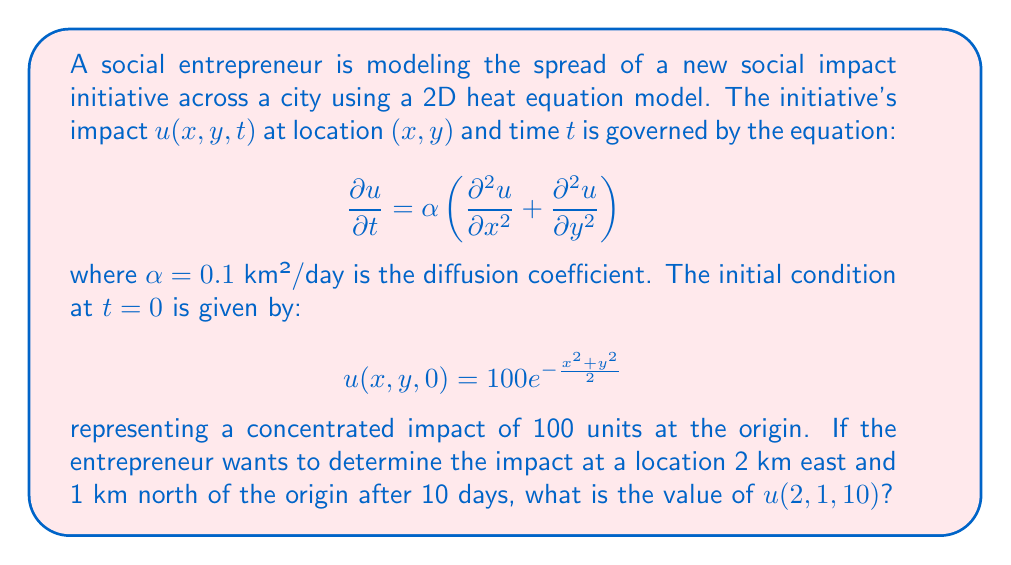Provide a solution to this math problem. To solve this problem, we need to use the fundamental solution of the 2D heat equation. The solution for an initial point source $\delta(x,y)$ at the origin is:

$$u(x,y,t) = \frac{1}{4\pi\alpha t}e^{-\frac{x^2+y^2}{4\alpha t}}$$

For our initial condition, we have a Gaussian distribution instead of a point source. We can use the principle of superposition and convolution to find the solution:

$$u(x,y,t) = \frac{100}{4\pi\alpha t + 1}e^{-\frac{x^2+y^2}{4\alpha t + 2}}$$

Now, we need to calculate $u(2,1,10)$:

1. Calculate $4\pi\alpha t + 1$:
   $4\pi \cdot 0.1 \cdot 10 + 1 = 4\pi + 1 \approx 13.5664$

2. Calculate $4\alpha t + 2$:
   $4 \cdot 0.1 \cdot 10 + 2 = 6$

3. Calculate $\frac{x^2+y^2}{4\alpha t + 2}$:
   $\frac{2^2 + 1^2}{6} = \frac{5}{6} \approx 0.8333$

4. Substitute these values into the solution:

   $$u(2,1,10) = \frac{100}{13.5664}e^{-0.8333} \approx 3.2398$$
Answer: $u(2,1,10) \approx 3.2398$ impact units 